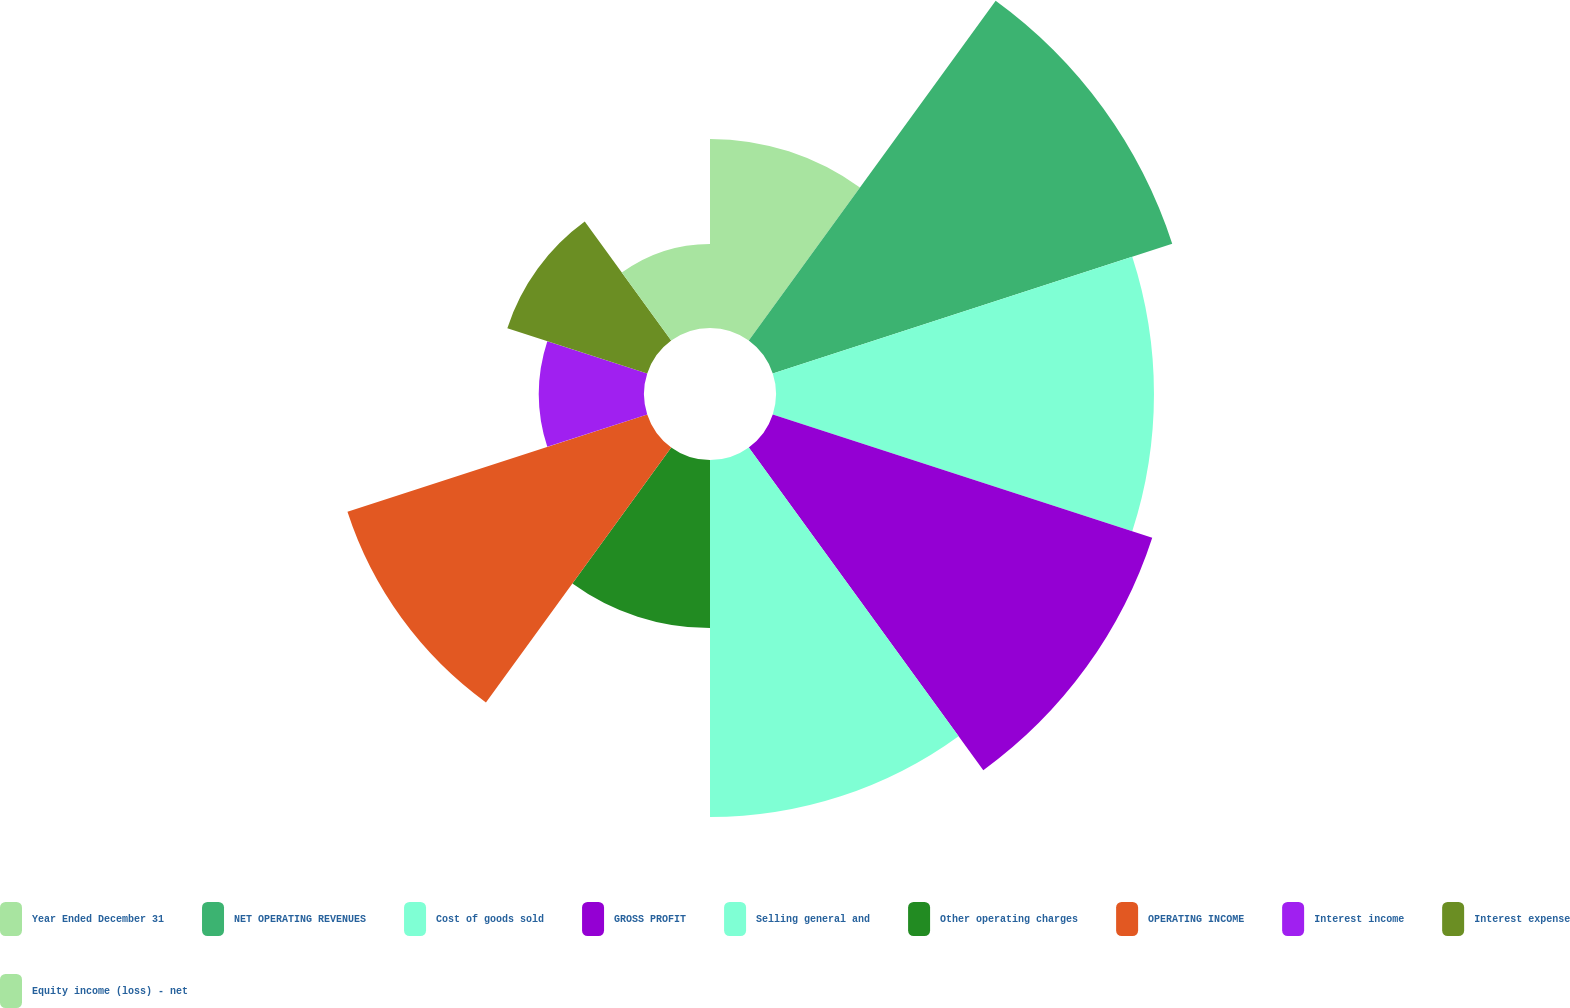<chart> <loc_0><loc_0><loc_500><loc_500><pie_chart><fcel>Year Ended December 31<fcel>NET OPERATING REVENUES<fcel>Cost of goods sold<fcel>GROSS PROFIT<fcel>Selling general and<fcel>Other operating charges<fcel>OPERATING INCOME<fcel>Interest income<fcel>Interest expense<fcel>Equity income (loss) - net<nl><fcel>7.38%<fcel>16.39%<fcel>14.75%<fcel>15.57%<fcel>13.93%<fcel>6.56%<fcel>12.3%<fcel>4.1%<fcel>5.74%<fcel>3.28%<nl></chart> 